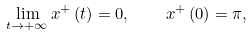Convert formula to latex. <formula><loc_0><loc_0><loc_500><loc_500>\lim _ { t \rightarrow + \infty } x ^ { + } \left ( t \right ) = 0 , \quad x ^ { + } \left ( 0 \right ) = \pi ,</formula> 